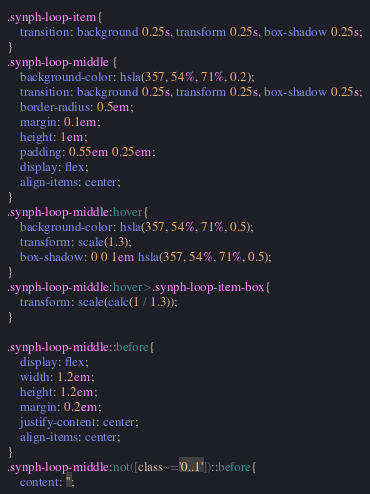<code> <loc_0><loc_0><loc_500><loc_500><_CSS_>.synph-loop-item{
    transition: background 0.25s, transform 0.25s, box-shadow 0.25s;
}
.synph-loop-middle {
    background-color: hsla(357, 54%, 71%, 0.2);
    transition: background 0.25s, transform 0.25s, box-shadow 0.25s;
    border-radius: 0.5em;
    margin: 0.1em;
    height: 1em;
    padding: 0.55em 0.25em;
    display: flex;
    align-items: center;
}
.synph-loop-middle:hover{
    background-color: hsla(357, 54%, 71%, 0.5);
    transform: scale(1.3);
    box-shadow: 0 0 1em hsla(357, 54%, 71%, 0.5);
}
.synph-loop-middle:hover>.synph-loop-item-box{
    transform: scale(calc(1 / 1.3));
}

.synph-loop-middle::before{
    display: flex;
    width: 1.2em;
    height: 1.2em;
    margin: 0.2em;
    justify-content: center;
    align-items: center;
}
.synph-loop-middle:not([class~='0..1'])::before{
    content: '';</code> 